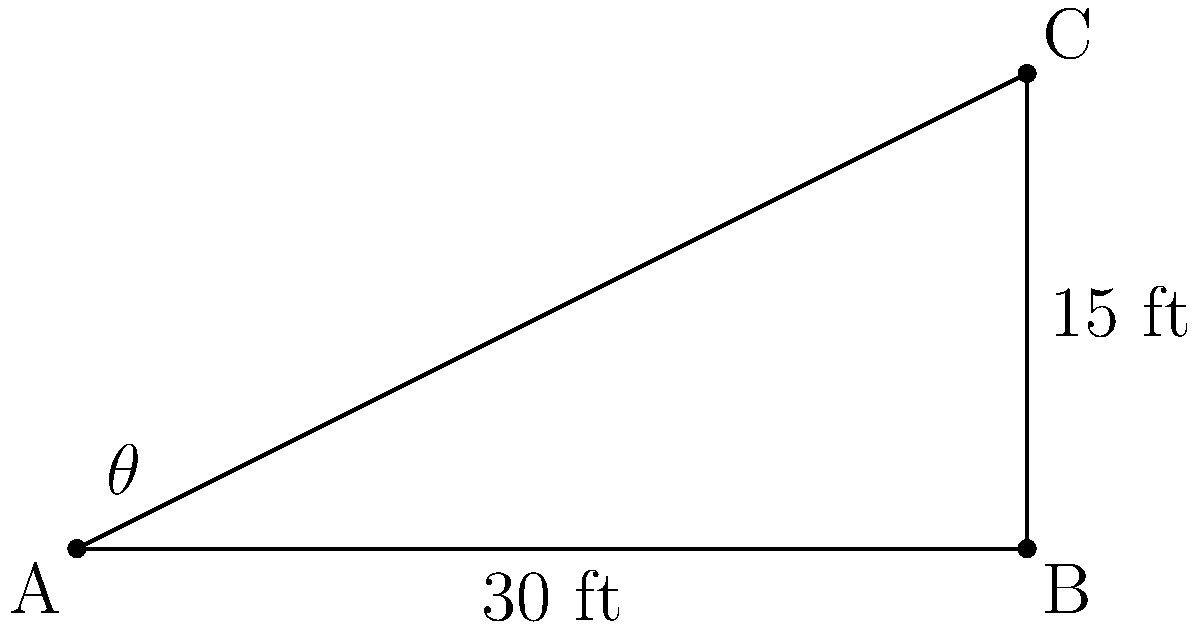In "Back to the Future," Doc Brown needs to calculate the angle of inclination for the DeLorean's ramp to reach 88 mph. If the ramp is 30 feet long and reaches a height of 15 feet, what is the angle of inclination (θ) in degrees? (Round your answer to the nearest whole number.) Let's approach this step-by-step, using our knowledge of trigonometry and right triangles:

1) We have a right triangle where:
   - The base (adjacent to the angle) is 30 feet
   - The height (opposite to the angle) is 15 feet
   - We need to find the angle θ

2) In this scenario, we can use the tangent function, which is defined as:

   $\tan(\theta) = \frac{\text{opposite}}{\text{adjacent}}$

3) Plugging in our values:

   $\tan(\theta) = \frac{15}{30} = \frac{1}{2} = 0.5$

4) To find θ, we need to use the inverse tangent (arctan or tan^(-1)):

   $\theta = \tan^{-1}(0.5)$

5) Using a calculator or trigonometric tables:

   $\theta \approx 26.57°$

6) Rounding to the nearest whole number:

   $\theta \approx 27°$

This 27° angle would allow the DeLorean to reach the required speed of 88 mph, just like in the movie!
Answer: 27° 